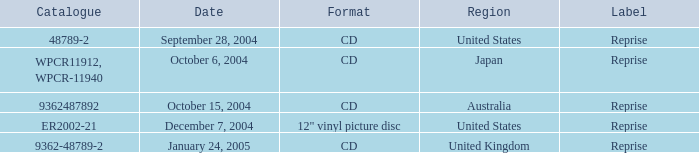Name the october 15, 2004 catalogue 9362487892.0. 